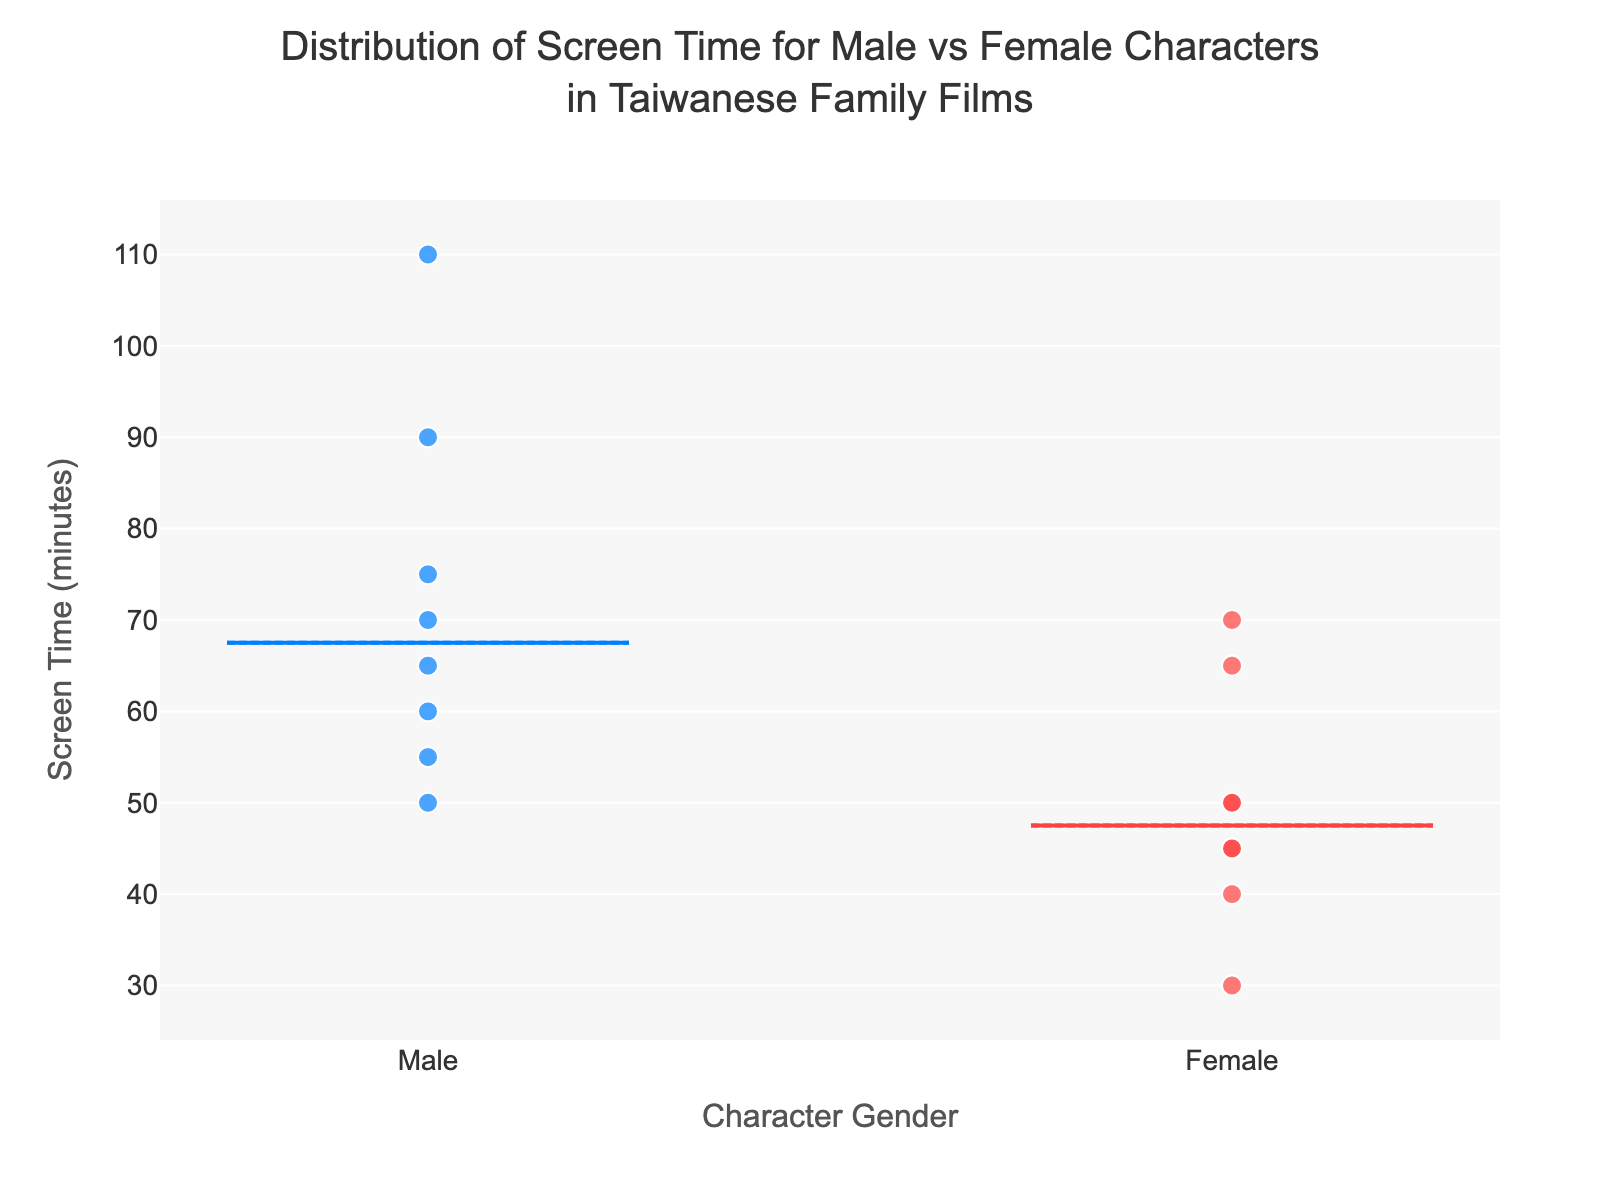What are the median screen times for male and female characters? The median screen time for each gender is indicated by the center line within each box. The median for male characters is shown at 62.5 minutes, and for female characters is shown at 47.5 minutes.
Answer: Male: 62.5, Female: 47.5 What is the range of screen time for male characters? The range is determined by the difference between the maximum and minimum values. For male characters, the minimum screen time is 50 minutes and the maximum is 110 minutes, so the range is 110 - 50 = 60 minutes.
Answer: 60 minutes Which gender has a higher interquartile range (IQR) of screen time? IQR is calculated as Q3 - Q1. For male characters, Q3 is 72.5 and Q1 is 55, giving an IQR of 72.5 - 55 = 17.5 minutes. For female characters, Q3 is 57.5 and Q1 is 42.5, giving an IQR of 57.5 - 42.5 = 15 minutes. Therefore, male characters have a higher IQR.
Answer: Male Do any female characters have a screen time higher than the median screen time of male characters? The female box plot does not show individual data points at a higher value than the male median (62.5). However, by looking at individual points, the screen time for one female character (Our Times) is as high as 70 minutes, which is higher than 62.5.
Answer: Yes What is the maximum screen time recorded for female characters? The maximum screen time for female characters corresponds to the top whisker of the female box plot, which shows 70 minutes.
Answer: 70 minutes Which film has the longest screen time for a male character? Each data point is labeled with the film title. The data point for "A Brighter Summer Day" has the longest screen time at 110 minutes.
Answer: A Brighter Summer Day Which gender shows more variability in screen time based on the box plot? Variability can be assessed by the spread of the box plots. The male box plot shows a wider interquartile range and overall range compared to the female box plot, indicating higher variability.
Answer: Male What are the upper fences for both male and female screen times? The upper fences are calculated as Q3 + 1.5 * IQR. For males: Q3 = 72.5, IQR = 17.5, so upper fence = 72.5 + 1.5 * 17.5 = 99.75 minutes. For females: Q3 = 57.5, IQR = 15, so upper fence = 57.5 + 1.5 * 15 = 80 minutes.
Answer: Male: 99.75, Female: 80 Are there any outliers in the screen times of male or female characters based on the data provided? By checking if any individual points lie beyond the calculated upper or lower fences, and since no points appear outside these ranges, it indicates there are no outliers.
Answer: No 